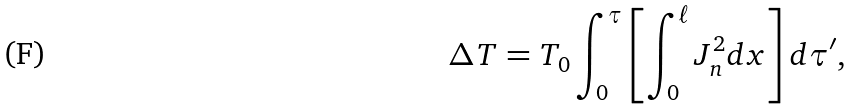Convert formula to latex. <formula><loc_0><loc_0><loc_500><loc_500>\Delta T = T _ { 0 } \int _ { 0 } ^ { \tau } \left [ \int _ { 0 } ^ { \ell } J _ { n } ^ { 2 } d x \right ] d \tau ^ { \prime } ,</formula> 